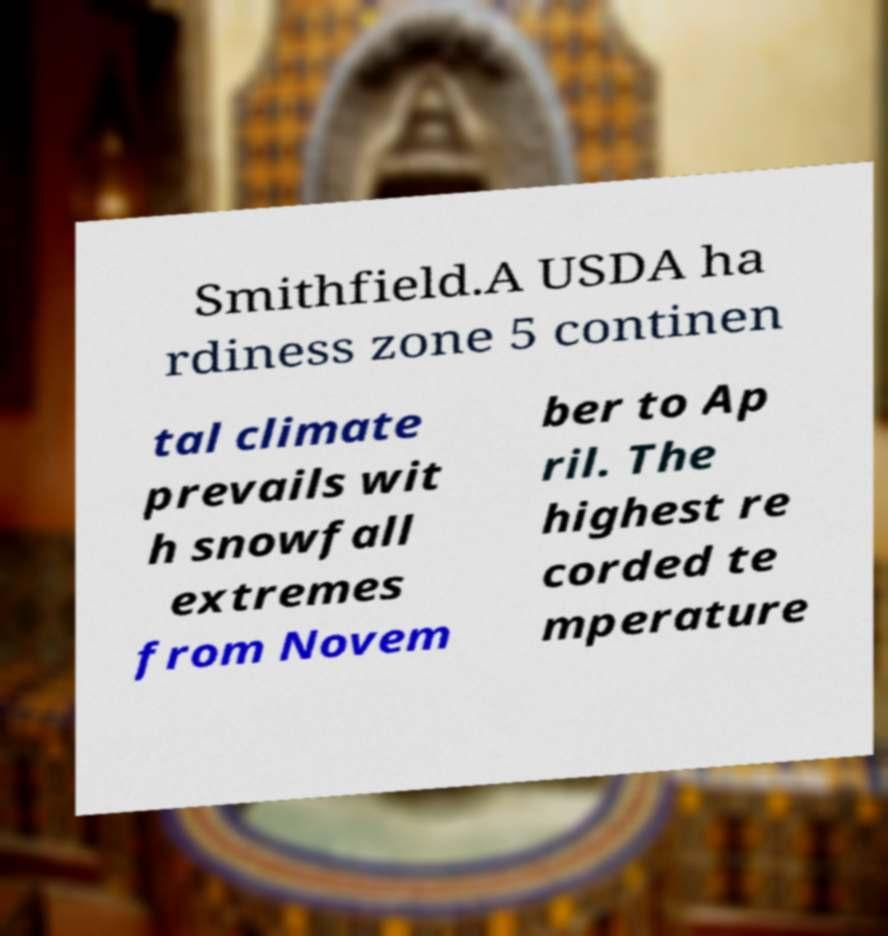There's text embedded in this image that I need extracted. Can you transcribe it verbatim? Smithfield.A USDA ha rdiness zone 5 continen tal climate prevails wit h snowfall extremes from Novem ber to Ap ril. The highest re corded te mperature 